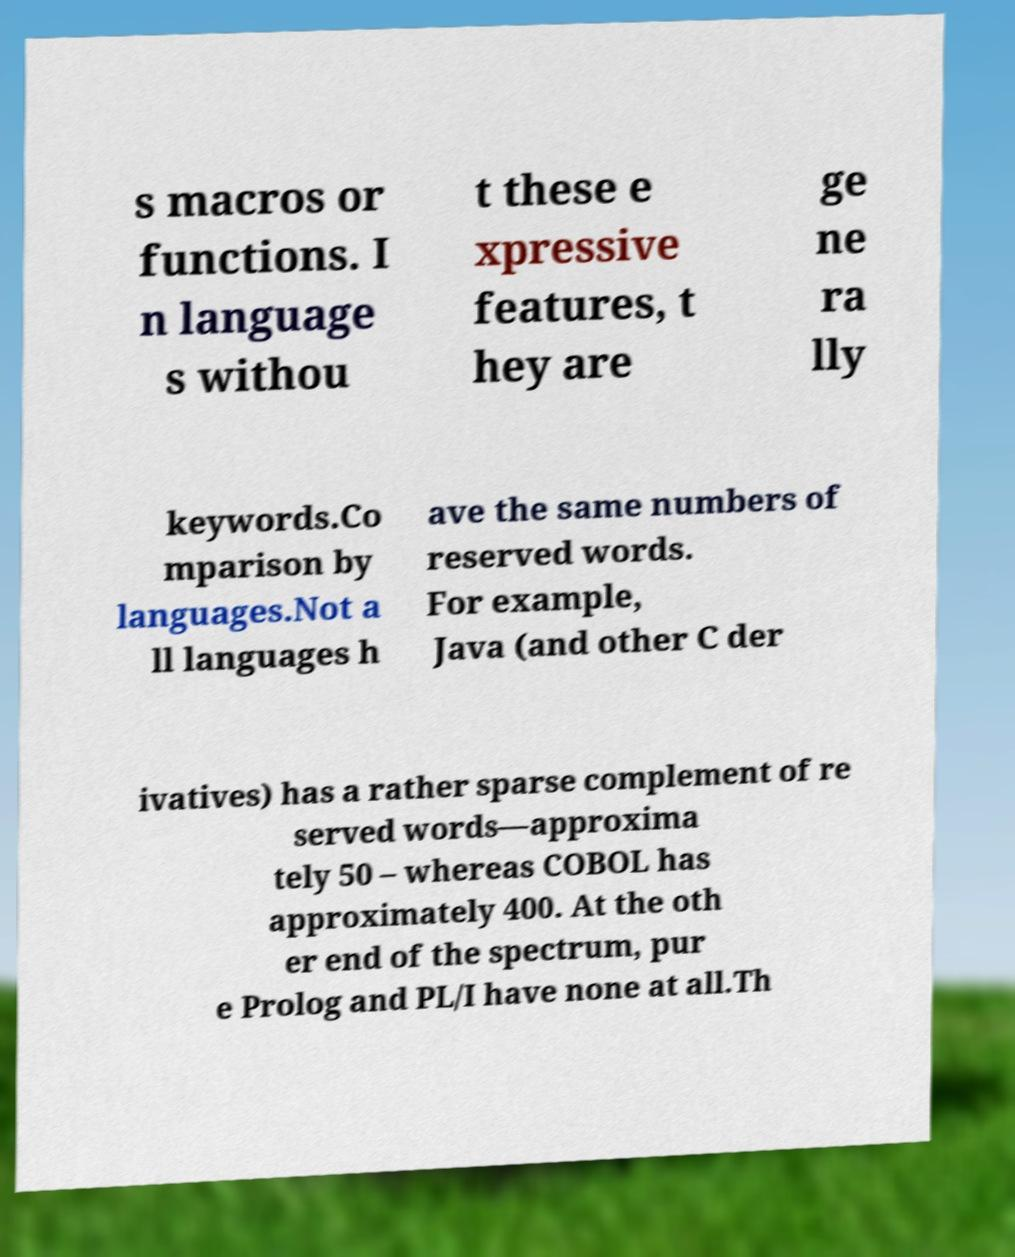For documentation purposes, I need the text within this image transcribed. Could you provide that? s macros or functions. I n language s withou t these e xpressive features, t hey are ge ne ra lly keywords.Co mparison by languages.Not a ll languages h ave the same numbers of reserved words. For example, Java (and other C der ivatives) has a rather sparse complement of re served words—approxima tely 50 – whereas COBOL has approximately 400. At the oth er end of the spectrum, pur e Prolog and PL/I have none at all.Th 